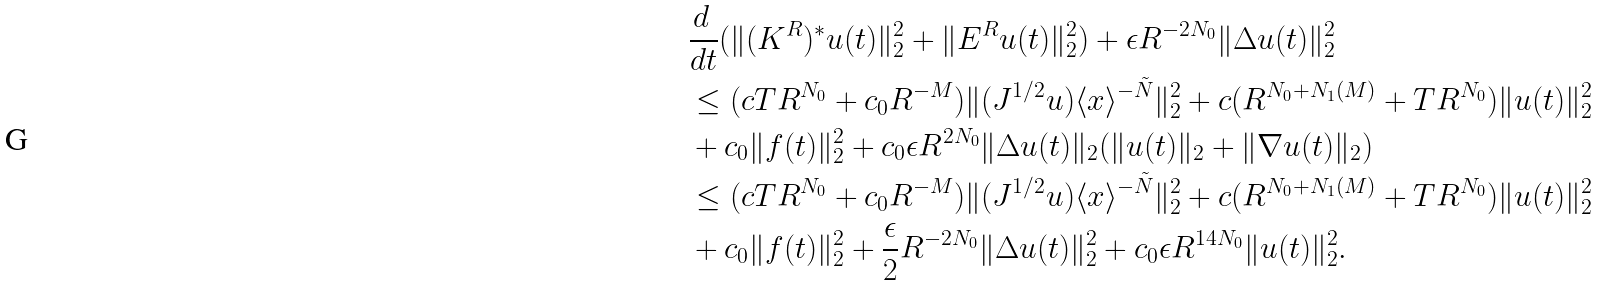<formula> <loc_0><loc_0><loc_500><loc_500>& \frac { d \, } { d t } ( \| ( K ^ { R } ) ^ { * } u ( t ) \| _ { 2 } ^ { 2 } + \| E ^ { R } u ( t ) \| ^ { 2 } _ { 2 } ) + \epsilon R ^ { - 2 N _ { 0 } } \| \Delta u ( t ) \| _ { 2 } ^ { 2 } \\ & \leq ( c T R ^ { N _ { 0 } } + c _ { 0 } R ^ { - M } ) \| ( J ^ { 1 / 2 } u ) \langle x \rangle ^ { - \tilde { N } } \| _ { 2 } ^ { 2 } + c ( R ^ { N _ { 0 } + N _ { 1 } ( M ) } + T R ^ { N _ { 0 } } ) \| u ( t ) \| _ { 2 } ^ { 2 } \\ & + c _ { 0 } \| f ( t ) \| _ { 2 } ^ { 2 } + c _ { 0 } \epsilon R ^ { 2 N _ { 0 } } \| \Delta u ( t ) \| _ { 2 } ( \| u ( t ) \| _ { 2 } + \| \nabla u ( t ) \| _ { 2 } ) \\ & \leq ( c T R ^ { N _ { 0 } } + c _ { 0 } R ^ { - M } ) \| ( J ^ { 1 / 2 } u ) \langle x \rangle ^ { - \tilde { N } } \| _ { 2 } ^ { 2 } + c ( R ^ { N _ { 0 } + N _ { 1 } ( M ) } + T R ^ { N _ { 0 } } ) \| u ( t ) \| _ { 2 } ^ { 2 } \\ & + c _ { 0 } \| f ( t ) \| _ { 2 } ^ { 2 } + \frac { \epsilon } { 2 } R ^ { - 2 N _ { 0 } } \| \Delta u ( t ) \| _ { 2 } ^ { 2 } + c _ { 0 } \epsilon R ^ { 1 4 N _ { 0 } } \| u ( t ) \| _ { 2 } ^ { 2 } .</formula> 